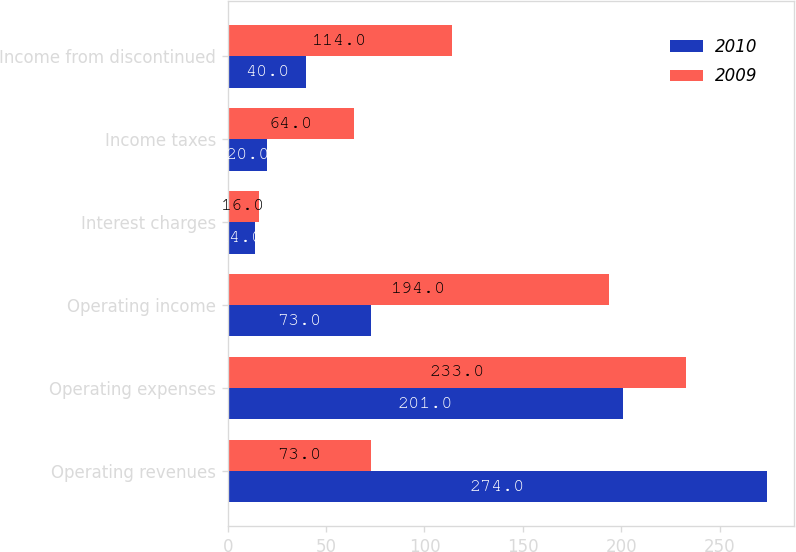Convert chart to OTSL. <chart><loc_0><loc_0><loc_500><loc_500><stacked_bar_chart><ecel><fcel>Operating revenues<fcel>Operating expenses<fcel>Operating income<fcel>Interest charges<fcel>Income taxes<fcel>Income from discontinued<nl><fcel>2010<fcel>274<fcel>201<fcel>73<fcel>14<fcel>20<fcel>40<nl><fcel>2009<fcel>73<fcel>233<fcel>194<fcel>16<fcel>64<fcel>114<nl></chart> 